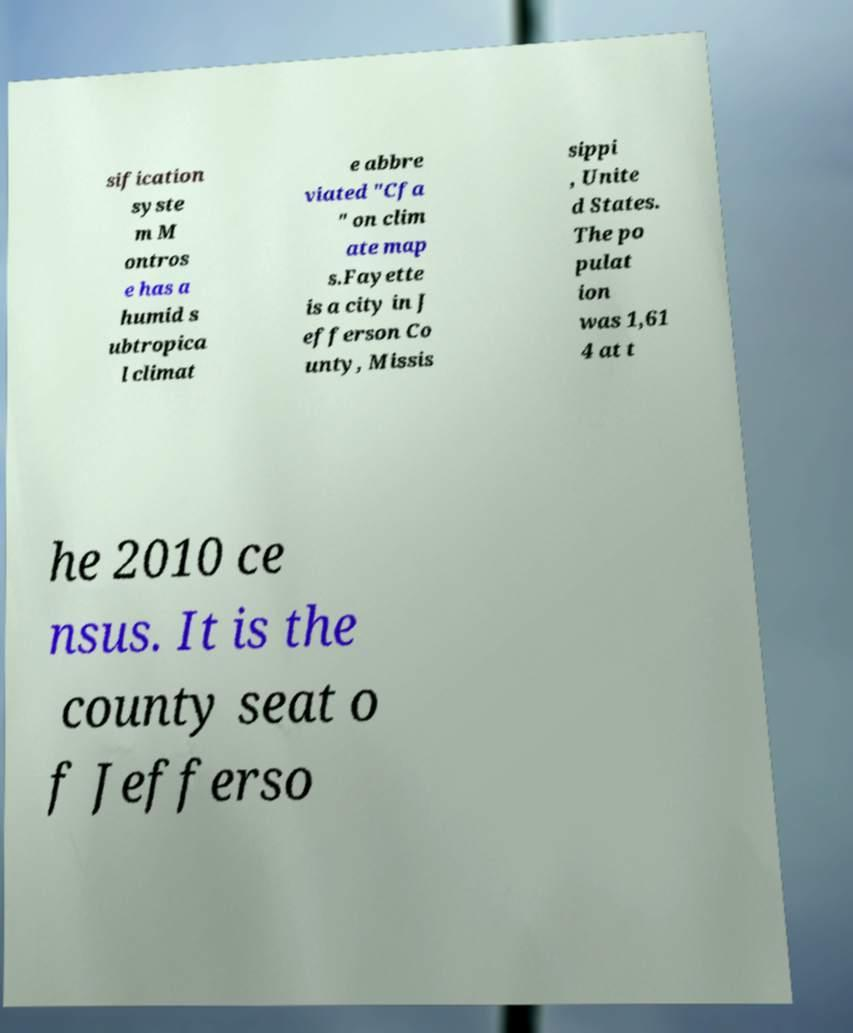Could you extract and type out the text from this image? sification syste m M ontros e has a humid s ubtropica l climat e abbre viated "Cfa " on clim ate map s.Fayette is a city in J efferson Co unty, Missis sippi , Unite d States. The po pulat ion was 1,61 4 at t he 2010 ce nsus. It is the county seat o f Jefferso 